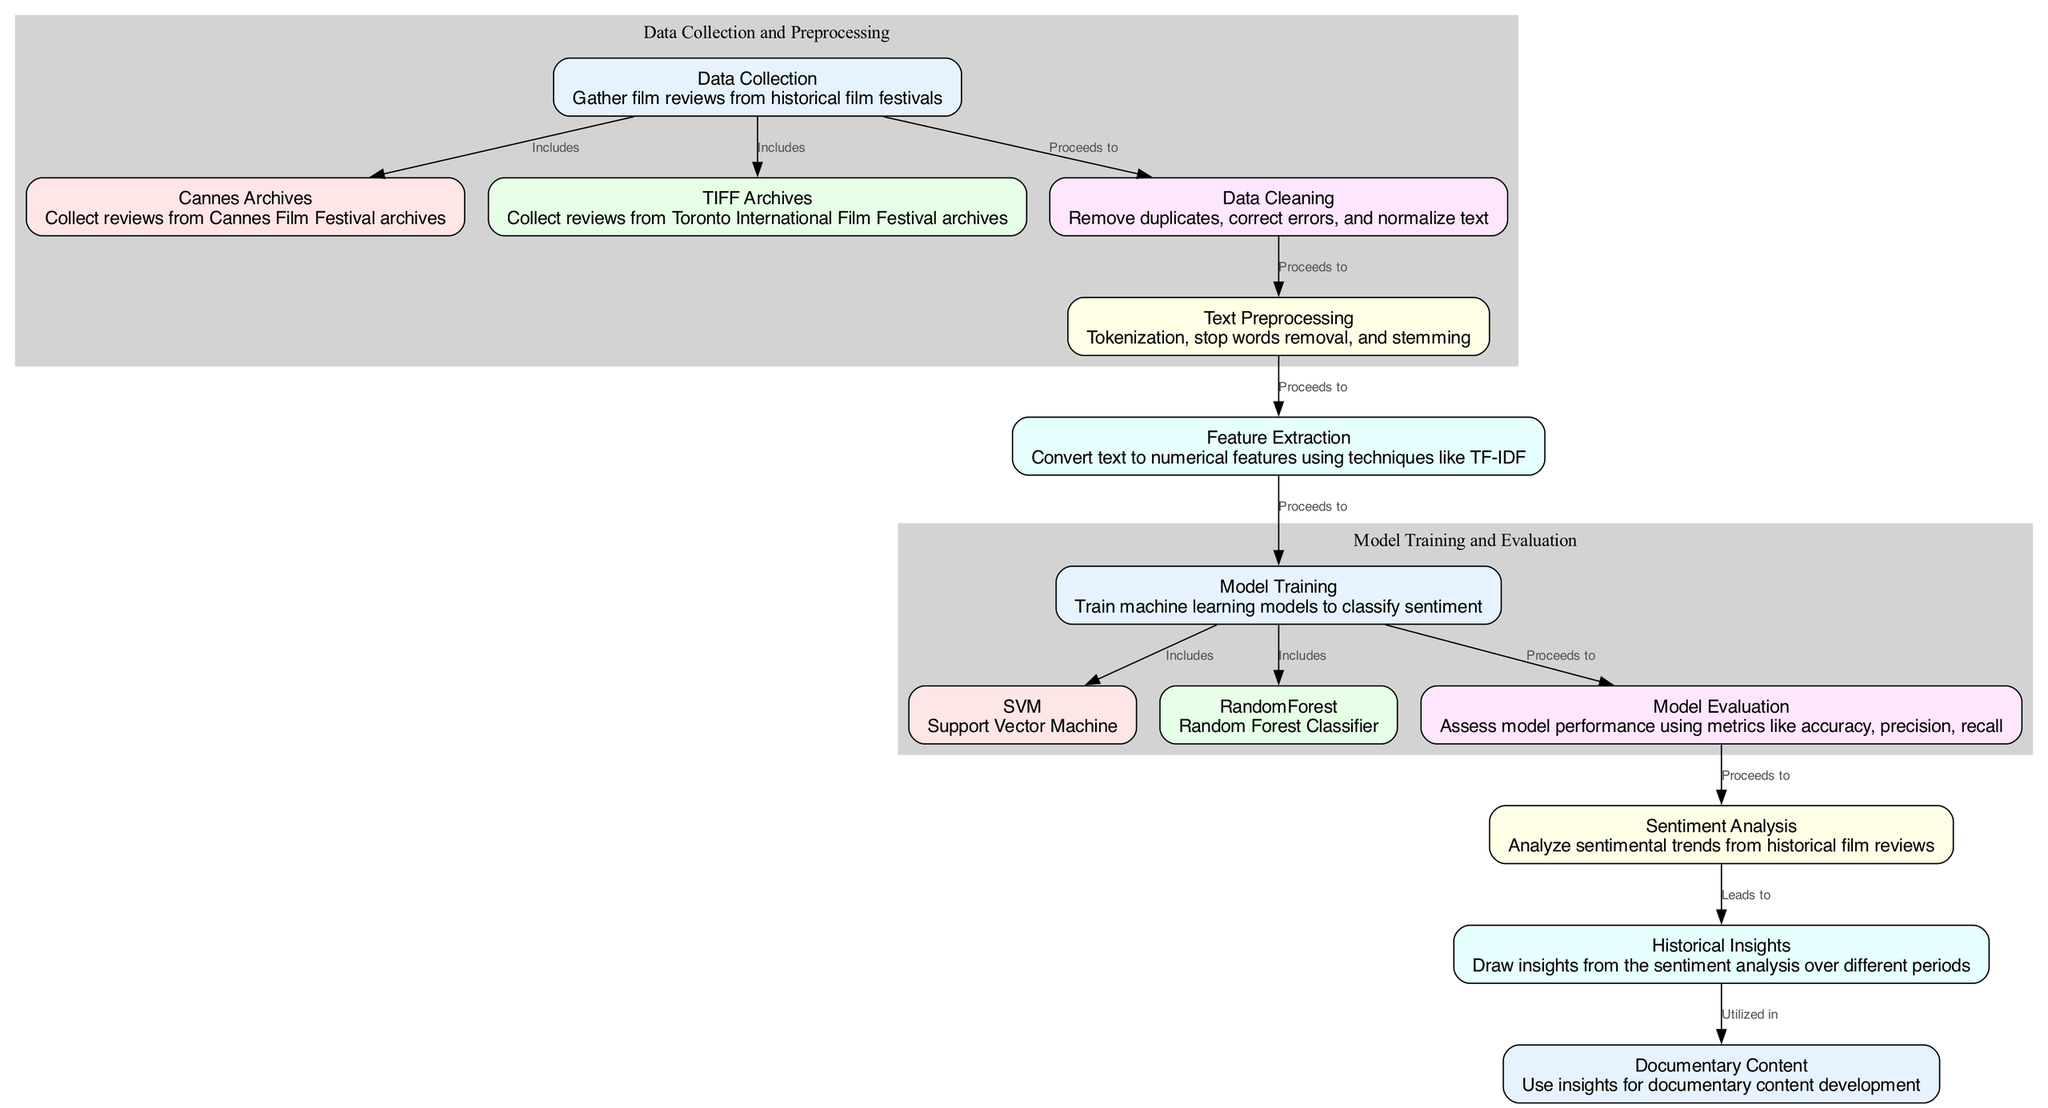What are the two data sources used for film reviews? The diagram indicates two data sources: Cannes Archives and TIFF Archives, both of which are listed as part of the Data Collection process.
Answer: Cannes Archives, TIFF Archives How many nodes are in the diagram? By counting the nodes presented in the diagram, we identify a total of 13 nodes that represent various stages of the sentiment analysis process.
Answer: 13 Which model is included in model training? The diagram specifies two models included in the model training phase: Support Vector Machine and Random Forest Classifier.
Answer: Support Vector Machine, Random Forest Classifier What process comes after data cleaning? According to the diagram, the next process after data cleaning is text preprocessing, indicating the sequential flow from cleaning to preparing the data for analysis.
Answer: Text Preprocessing Which statistical metrics are used for model evaluation? The diagram mentions accuracy, precision, and recall as metrics for assessing model performance during the model evaluation stage.
Answer: Accuracy, precision, recall How does sentiment analysis lead to documentary content? The diagram shows that sentiment analysis leads directly to historical insights, which are then utilized in developing documentary content, indicating a logical progression from analysis to application.
Answer: Historical insights What is the main output of the sentiment analysis process? The primary output of the sentiment analysis process is historical insights, suggesting a broader understanding derived from the sentiment of film reviews over time.
Answer: Historical insights What element precedes feature extraction? The diagram illustrates that preprocessing precedes feature extraction, showing a clear pathway in the data processing workflow leading to the extraction of numerical features.
Answer: Preprocessing What is the main purpose of data cleaning? The data cleaning stage aims to remove duplicates, correct errors, and normalize text, ensuring that the data is in the best condition for subsequent processes.
Answer: Remove duplicates, correct errors, normalize text 